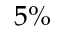<formula> <loc_0><loc_0><loc_500><loc_500>5 \%</formula> 